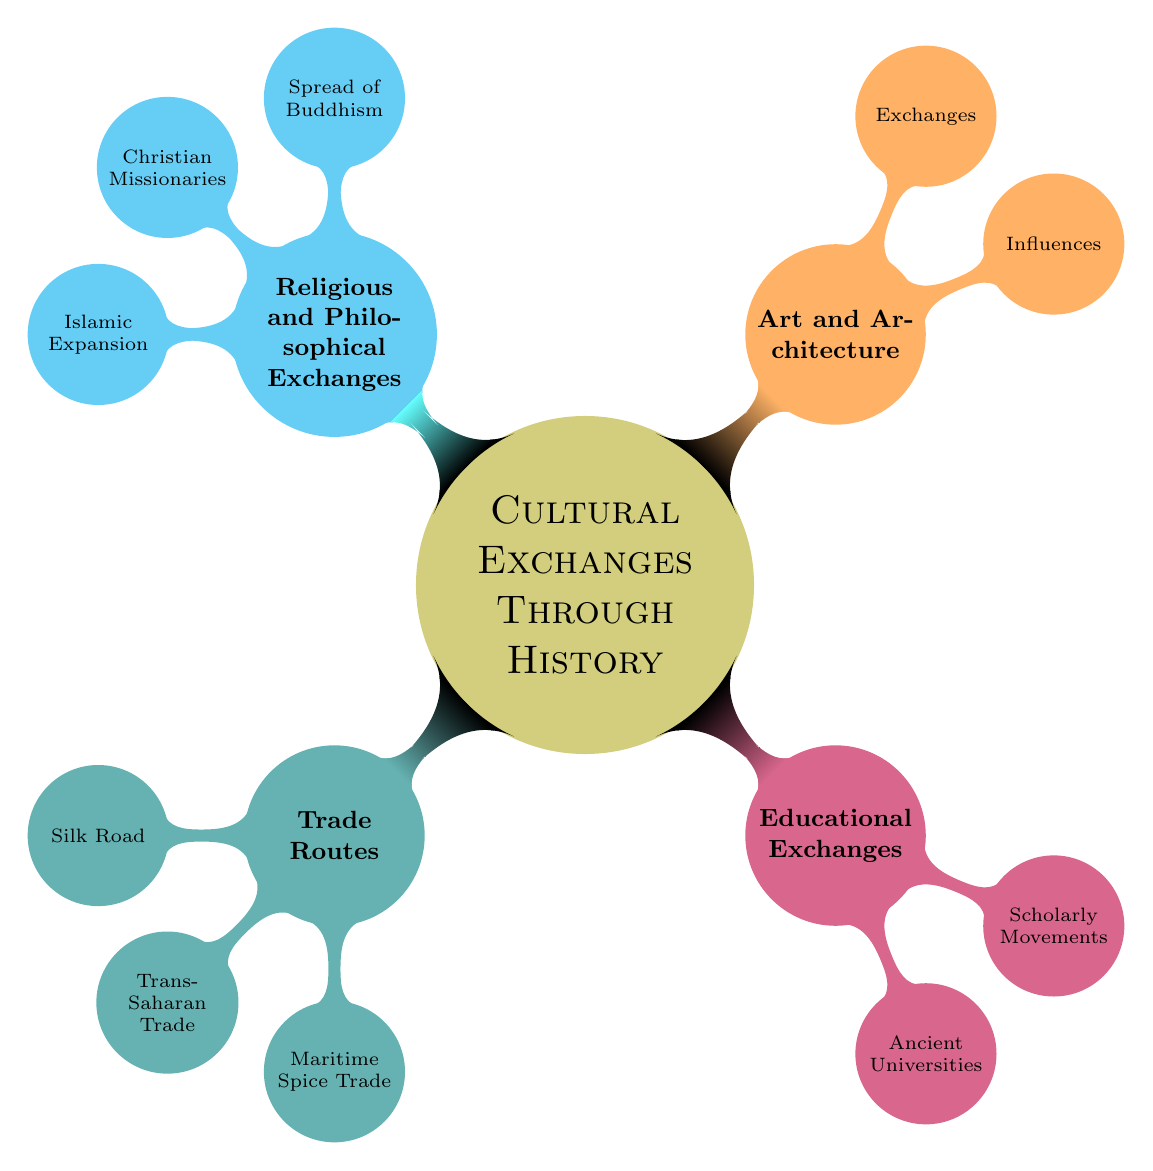What are the three main categories of cultural exchanges shown in the diagram? The diagram includes four main categories: Trade Routes, Educational Exchanges, Art and Architecture, and Religious and Philosophical Exchanges.
Answer: Trade Routes, Educational Exchanges, Art and Architecture, Religious and Philosophical Exchanges How many trade routes are listed in the diagram? There are three trade routes listed: Silk Road, Trans-Saharan Trade, and Maritime Spice Trade. Counting these gives the total as three.
Answer: 3 Which country is associated with the Maritime Spice Trade? The Maritime Spice Trade includes India, which is one of the countries mentioned under this trade route in the diagram.
Answer: India What does the category "Educational Exchanges" consist of? The "Educational Exchanges" category consists of two subcategories: Ancient Universities and Scholarly Movements.
Answer: Ancient Universities, Scholarly Movements Which specific influence from Islamic culture is noted in the "Exchanges" category? The diagram specifically mentions "Islamic Influence on Spanish Architecture (Al-Andalus)" as an example of exchange in the Art and Architecture category.
Answer: Islamic Influence on Spanish Architecture (Al-Andalus) What is the relationship between the spread of Buddhism and the countries listed? The relationship is that the spread of Buddhism is noted to have occurred in three countries: India, China, and Japan, indicating an exchange of religious ideas across these regions.
Answer: India, China, Japan How many types of influences are mentioned under Art and Architecture? Two types of influences are listed in the diagram under Art and Architecture: Influences and Exchanges, which indicates a total of two different types.
Answer: 2 Which ancient university is mentioned first in the diagram? Nalanda University (India) is the first institution mentioned under the Ancient Universities subcategory in the diagram.
Answer: Nalanda University (India) What region is associated with the spread of Islamic culture in the diagram? The spread of Islamic culture is associated with multiple regions, specifically the Middle East, North Africa, and the Iberian Peninsula.
Answer: Middle East, North Africa, Iberian Peninsula 